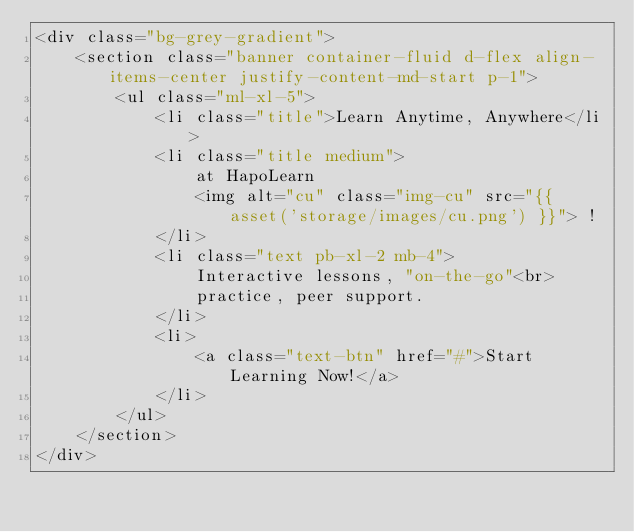<code> <loc_0><loc_0><loc_500><loc_500><_PHP_><div class="bg-grey-gradient">
    <section class="banner container-fluid d-flex align-items-center justify-content-md-start p-1">
        <ul class="ml-xl-5">
            <li class="title">Learn Anytime, Anywhere</li>
            <li class="title medium">
                at HapoLearn 
                <img alt="cu" class="img-cu" src="{{ asset('storage/images/cu.png') }}"> !
            </li>
            <li class="text pb-xl-2 mb-4">
                Interactive lessons, "on-the-go"<br>
                practice, peer support.
            </li>
            <li>
                <a class="text-btn" href="#">Start Learning Now!</a>
            </li>
        </ul>
    </section>
</div>
</code> 